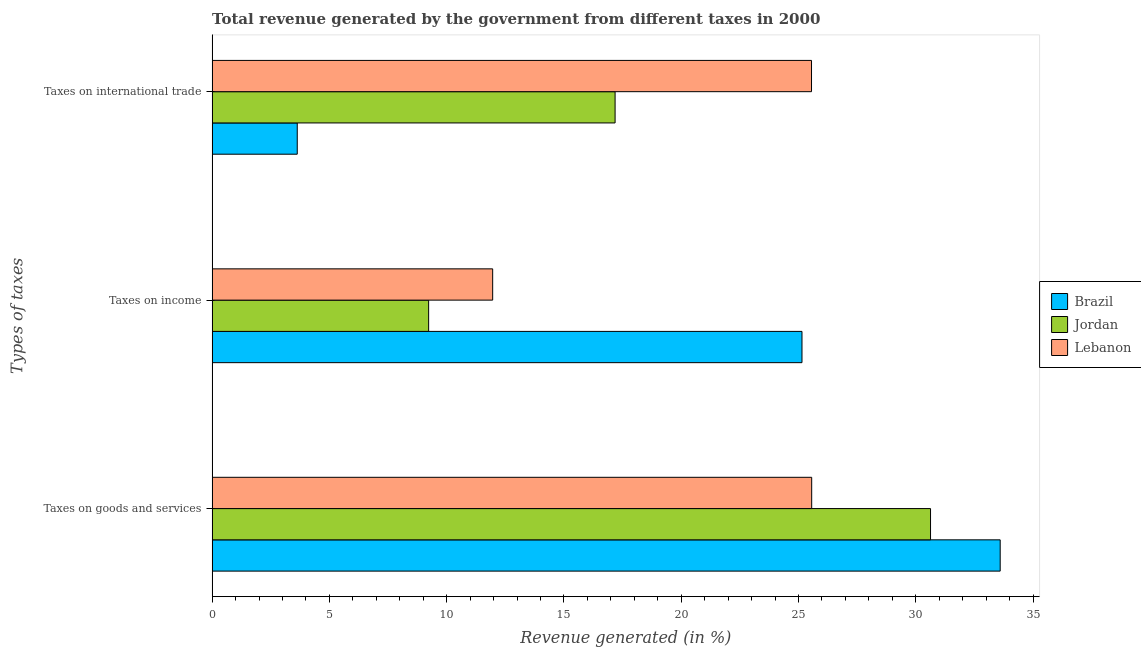How many groups of bars are there?
Give a very brief answer. 3. Are the number of bars per tick equal to the number of legend labels?
Ensure brevity in your answer.  Yes. Are the number of bars on each tick of the Y-axis equal?
Ensure brevity in your answer.  Yes. How many bars are there on the 2nd tick from the top?
Keep it short and to the point. 3. What is the label of the 1st group of bars from the top?
Your answer should be very brief. Taxes on international trade. What is the percentage of revenue generated by tax on international trade in Lebanon?
Your response must be concise. 25.56. Across all countries, what is the maximum percentage of revenue generated by taxes on income?
Ensure brevity in your answer.  25.15. Across all countries, what is the minimum percentage of revenue generated by taxes on goods and services?
Ensure brevity in your answer.  25.56. In which country was the percentage of revenue generated by taxes on goods and services minimum?
Provide a short and direct response. Lebanon. What is the total percentage of revenue generated by taxes on goods and services in the graph?
Ensure brevity in your answer.  89.79. What is the difference between the percentage of revenue generated by taxes on income in Jordan and that in Lebanon?
Your answer should be compact. -2.73. What is the difference between the percentage of revenue generated by tax on international trade in Jordan and the percentage of revenue generated by taxes on goods and services in Brazil?
Provide a succinct answer. -16.42. What is the average percentage of revenue generated by tax on international trade per country?
Offer a terse response. 15.46. What is the difference between the percentage of revenue generated by tax on international trade and percentage of revenue generated by taxes on goods and services in Brazil?
Give a very brief answer. -29.97. In how many countries, is the percentage of revenue generated by tax on international trade greater than 21 %?
Your answer should be compact. 1. What is the ratio of the percentage of revenue generated by tax on international trade in Brazil to that in Jordan?
Your answer should be very brief. 0.21. What is the difference between the highest and the second highest percentage of revenue generated by taxes on income?
Provide a succinct answer. 13.19. What is the difference between the highest and the lowest percentage of revenue generated by tax on international trade?
Ensure brevity in your answer.  21.93. In how many countries, is the percentage of revenue generated by taxes on goods and services greater than the average percentage of revenue generated by taxes on goods and services taken over all countries?
Provide a succinct answer. 2. What does the 2nd bar from the top in Taxes on income represents?
Offer a terse response. Jordan. What does the 2nd bar from the bottom in Taxes on goods and services represents?
Make the answer very short. Jordan. Are all the bars in the graph horizontal?
Ensure brevity in your answer.  Yes. How many countries are there in the graph?
Provide a succinct answer. 3. What is the difference between two consecutive major ticks on the X-axis?
Provide a succinct answer. 5. How many legend labels are there?
Offer a very short reply. 3. What is the title of the graph?
Offer a very short reply. Total revenue generated by the government from different taxes in 2000. What is the label or title of the X-axis?
Offer a terse response. Revenue generated (in %). What is the label or title of the Y-axis?
Keep it short and to the point. Types of taxes. What is the Revenue generated (in %) of Brazil in Taxes on goods and services?
Keep it short and to the point. 33.6. What is the Revenue generated (in %) of Jordan in Taxes on goods and services?
Keep it short and to the point. 30.63. What is the Revenue generated (in %) of Lebanon in Taxes on goods and services?
Your answer should be compact. 25.56. What is the Revenue generated (in %) in Brazil in Taxes on income?
Ensure brevity in your answer.  25.15. What is the Revenue generated (in %) in Jordan in Taxes on income?
Keep it short and to the point. 9.23. What is the Revenue generated (in %) of Lebanon in Taxes on income?
Your answer should be very brief. 11.96. What is the Revenue generated (in %) in Brazil in Taxes on international trade?
Offer a terse response. 3.63. What is the Revenue generated (in %) in Jordan in Taxes on international trade?
Provide a succinct answer. 17.18. What is the Revenue generated (in %) in Lebanon in Taxes on international trade?
Ensure brevity in your answer.  25.56. Across all Types of taxes, what is the maximum Revenue generated (in %) of Brazil?
Provide a succinct answer. 33.6. Across all Types of taxes, what is the maximum Revenue generated (in %) of Jordan?
Provide a succinct answer. 30.63. Across all Types of taxes, what is the maximum Revenue generated (in %) in Lebanon?
Provide a succinct answer. 25.56. Across all Types of taxes, what is the minimum Revenue generated (in %) in Brazil?
Offer a terse response. 3.63. Across all Types of taxes, what is the minimum Revenue generated (in %) in Jordan?
Your response must be concise. 9.23. Across all Types of taxes, what is the minimum Revenue generated (in %) of Lebanon?
Ensure brevity in your answer.  11.96. What is the total Revenue generated (in %) in Brazil in the graph?
Your answer should be very brief. 62.38. What is the total Revenue generated (in %) of Jordan in the graph?
Your answer should be very brief. 57.04. What is the total Revenue generated (in %) in Lebanon in the graph?
Your answer should be compact. 63.08. What is the difference between the Revenue generated (in %) in Brazil in Taxes on goods and services and that in Taxes on income?
Provide a short and direct response. 8.45. What is the difference between the Revenue generated (in %) of Jordan in Taxes on goods and services and that in Taxes on income?
Keep it short and to the point. 21.4. What is the difference between the Revenue generated (in %) of Lebanon in Taxes on goods and services and that in Taxes on income?
Keep it short and to the point. 13.6. What is the difference between the Revenue generated (in %) of Brazil in Taxes on goods and services and that in Taxes on international trade?
Ensure brevity in your answer.  29.97. What is the difference between the Revenue generated (in %) of Jordan in Taxes on goods and services and that in Taxes on international trade?
Keep it short and to the point. 13.45. What is the difference between the Revenue generated (in %) in Lebanon in Taxes on goods and services and that in Taxes on international trade?
Your response must be concise. 0.01. What is the difference between the Revenue generated (in %) in Brazil in Taxes on income and that in Taxes on international trade?
Your answer should be very brief. 21.52. What is the difference between the Revenue generated (in %) of Jordan in Taxes on income and that in Taxes on international trade?
Ensure brevity in your answer.  -7.95. What is the difference between the Revenue generated (in %) of Lebanon in Taxes on income and that in Taxes on international trade?
Give a very brief answer. -13.59. What is the difference between the Revenue generated (in %) of Brazil in Taxes on goods and services and the Revenue generated (in %) of Jordan in Taxes on income?
Ensure brevity in your answer.  24.37. What is the difference between the Revenue generated (in %) of Brazil in Taxes on goods and services and the Revenue generated (in %) of Lebanon in Taxes on income?
Your answer should be very brief. 21.64. What is the difference between the Revenue generated (in %) of Jordan in Taxes on goods and services and the Revenue generated (in %) of Lebanon in Taxes on income?
Your response must be concise. 18.67. What is the difference between the Revenue generated (in %) in Brazil in Taxes on goods and services and the Revenue generated (in %) in Jordan in Taxes on international trade?
Give a very brief answer. 16.42. What is the difference between the Revenue generated (in %) of Brazil in Taxes on goods and services and the Revenue generated (in %) of Lebanon in Taxes on international trade?
Offer a very short reply. 8.04. What is the difference between the Revenue generated (in %) of Jordan in Taxes on goods and services and the Revenue generated (in %) of Lebanon in Taxes on international trade?
Give a very brief answer. 5.07. What is the difference between the Revenue generated (in %) in Brazil in Taxes on income and the Revenue generated (in %) in Jordan in Taxes on international trade?
Your answer should be compact. 7.97. What is the difference between the Revenue generated (in %) in Brazil in Taxes on income and the Revenue generated (in %) in Lebanon in Taxes on international trade?
Your answer should be very brief. -0.41. What is the difference between the Revenue generated (in %) in Jordan in Taxes on income and the Revenue generated (in %) in Lebanon in Taxes on international trade?
Offer a terse response. -16.32. What is the average Revenue generated (in %) of Brazil per Types of taxes?
Give a very brief answer. 20.79. What is the average Revenue generated (in %) of Jordan per Types of taxes?
Ensure brevity in your answer.  19.01. What is the average Revenue generated (in %) in Lebanon per Types of taxes?
Ensure brevity in your answer.  21.03. What is the difference between the Revenue generated (in %) of Brazil and Revenue generated (in %) of Jordan in Taxes on goods and services?
Your answer should be very brief. 2.97. What is the difference between the Revenue generated (in %) of Brazil and Revenue generated (in %) of Lebanon in Taxes on goods and services?
Provide a succinct answer. 8.04. What is the difference between the Revenue generated (in %) of Jordan and Revenue generated (in %) of Lebanon in Taxes on goods and services?
Your response must be concise. 5.07. What is the difference between the Revenue generated (in %) of Brazil and Revenue generated (in %) of Jordan in Taxes on income?
Your response must be concise. 15.92. What is the difference between the Revenue generated (in %) in Brazil and Revenue generated (in %) in Lebanon in Taxes on income?
Give a very brief answer. 13.19. What is the difference between the Revenue generated (in %) of Jordan and Revenue generated (in %) of Lebanon in Taxes on income?
Ensure brevity in your answer.  -2.73. What is the difference between the Revenue generated (in %) of Brazil and Revenue generated (in %) of Jordan in Taxes on international trade?
Your response must be concise. -13.55. What is the difference between the Revenue generated (in %) in Brazil and Revenue generated (in %) in Lebanon in Taxes on international trade?
Keep it short and to the point. -21.93. What is the difference between the Revenue generated (in %) of Jordan and Revenue generated (in %) of Lebanon in Taxes on international trade?
Give a very brief answer. -8.37. What is the ratio of the Revenue generated (in %) in Brazil in Taxes on goods and services to that in Taxes on income?
Provide a succinct answer. 1.34. What is the ratio of the Revenue generated (in %) in Jordan in Taxes on goods and services to that in Taxes on income?
Provide a succinct answer. 3.32. What is the ratio of the Revenue generated (in %) in Lebanon in Taxes on goods and services to that in Taxes on income?
Offer a very short reply. 2.14. What is the ratio of the Revenue generated (in %) of Brazil in Taxes on goods and services to that in Taxes on international trade?
Your answer should be compact. 9.26. What is the ratio of the Revenue generated (in %) of Jordan in Taxes on goods and services to that in Taxes on international trade?
Give a very brief answer. 1.78. What is the ratio of the Revenue generated (in %) in Brazil in Taxes on income to that in Taxes on international trade?
Provide a short and direct response. 6.93. What is the ratio of the Revenue generated (in %) in Jordan in Taxes on income to that in Taxes on international trade?
Ensure brevity in your answer.  0.54. What is the ratio of the Revenue generated (in %) in Lebanon in Taxes on income to that in Taxes on international trade?
Offer a very short reply. 0.47. What is the difference between the highest and the second highest Revenue generated (in %) in Brazil?
Provide a succinct answer. 8.45. What is the difference between the highest and the second highest Revenue generated (in %) in Jordan?
Your answer should be compact. 13.45. What is the difference between the highest and the second highest Revenue generated (in %) in Lebanon?
Offer a very short reply. 0.01. What is the difference between the highest and the lowest Revenue generated (in %) of Brazil?
Make the answer very short. 29.97. What is the difference between the highest and the lowest Revenue generated (in %) in Jordan?
Your answer should be compact. 21.4. What is the difference between the highest and the lowest Revenue generated (in %) in Lebanon?
Keep it short and to the point. 13.6. 